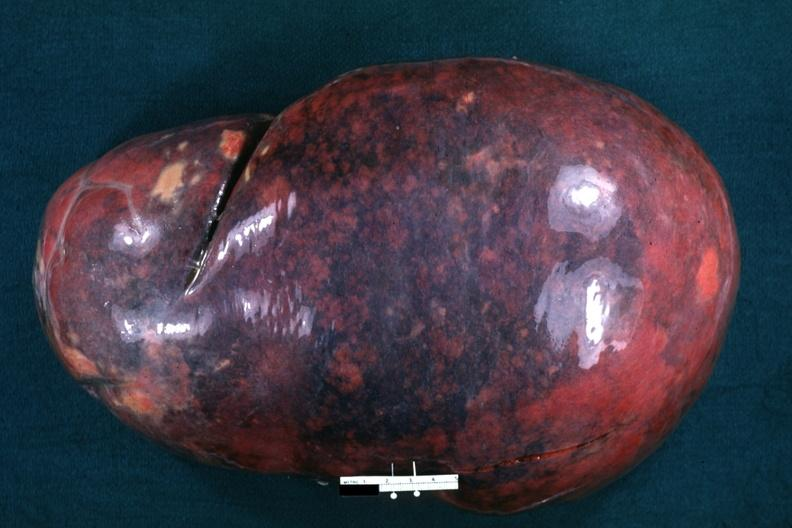s chronic myelogenous leukemia present?
Answer the question using a single word or phrase. Yes 